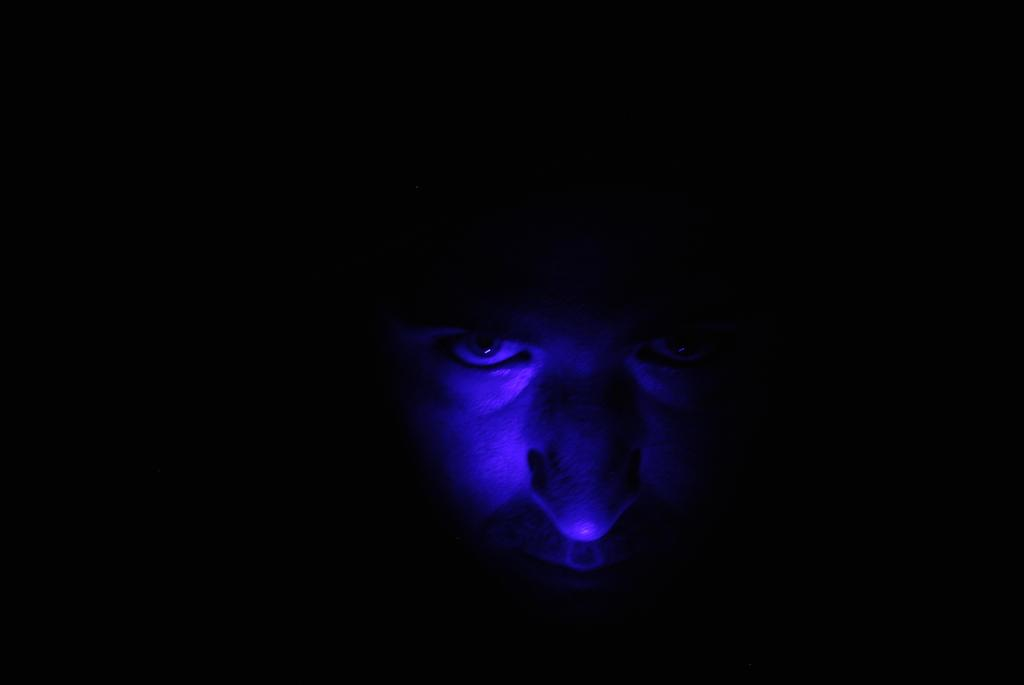What is the main subject of the image? The main subject of the image is the face of a person. What can be observed about the background of the image? The background of the image is dark. What type of beast can be seen in the market in the image? There is no market or beast present in the image; it features the face of a person with a dark background. 